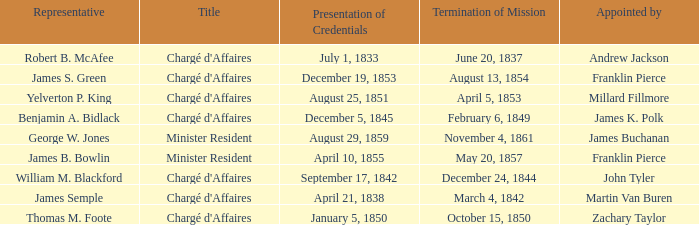What Title has a Termination of Mission of November 4, 1861? Minister Resident. 